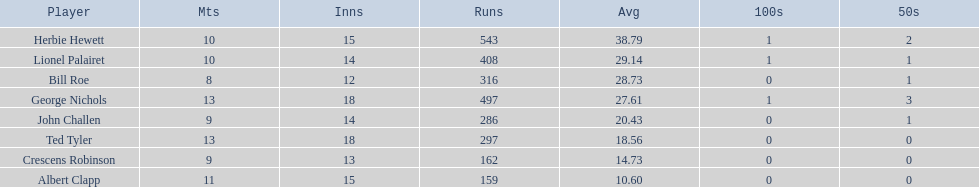Who are the players in somerset county cricket club in 1890? Herbie Hewett, Lionel Palairet, Bill Roe, George Nichols, John Challen, Ted Tyler, Crescens Robinson, Albert Clapp. Who is the only player to play less than 13 innings? Bill Roe. 